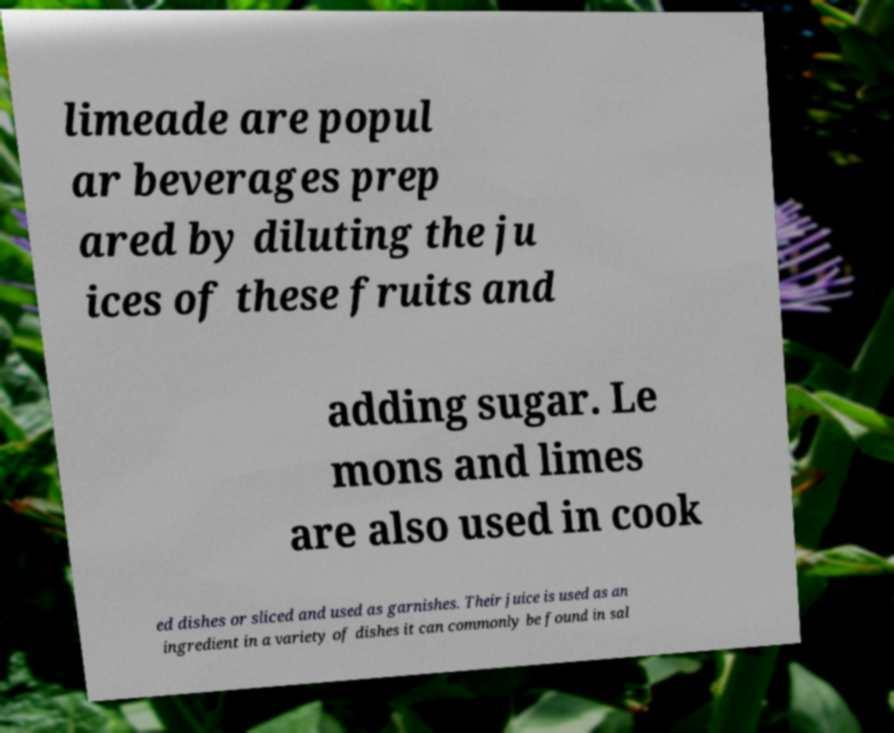Can you accurately transcribe the text from the provided image for me? limeade are popul ar beverages prep ared by diluting the ju ices of these fruits and adding sugar. Le mons and limes are also used in cook ed dishes or sliced and used as garnishes. Their juice is used as an ingredient in a variety of dishes it can commonly be found in sal 